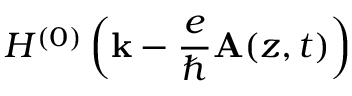<formula> <loc_0><loc_0><loc_500><loc_500>H ^ { ( 0 ) } \left ( { k } - \frac { e } { } { A } ( z , t ) \right )</formula> 